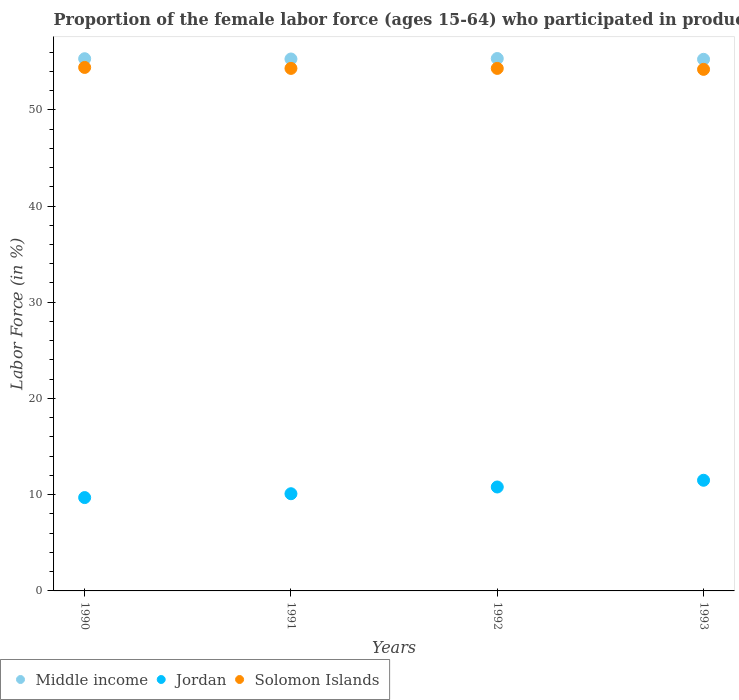What is the proportion of the female labor force who participated in production in Middle income in 1991?
Make the answer very short. 55.28. Across all years, what is the maximum proportion of the female labor force who participated in production in Jordan?
Provide a succinct answer. 11.5. Across all years, what is the minimum proportion of the female labor force who participated in production in Jordan?
Your answer should be compact. 9.7. In which year was the proportion of the female labor force who participated in production in Solomon Islands maximum?
Provide a succinct answer. 1990. What is the total proportion of the female labor force who participated in production in Solomon Islands in the graph?
Your response must be concise. 217.2. What is the difference between the proportion of the female labor force who participated in production in Middle income in 1990 and that in 1991?
Give a very brief answer. 0.03. What is the difference between the proportion of the female labor force who participated in production in Middle income in 1991 and the proportion of the female labor force who participated in production in Jordan in 1992?
Offer a very short reply. 44.48. What is the average proportion of the female labor force who participated in production in Middle income per year?
Your answer should be compact. 55.29. In the year 1993, what is the difference between the proportion of the female labor force who participated in production in Solomon Islands and proportion of the female labor force who participated in production in Jordan?
Your answer should be very brief. 42.7. What is the ratio of the proportion of the female labor force who participated in production in Solomon Islands in 1991 to that in 1993?
Your response must be concise. 1. Is the difference between the proportion of the female labor force who participated in production in Solomon Islands in 1991 and 1992 greater than the difference between the proportion of the female labor force who participated in production in Jordan in 1991 and 1992?
Ensure brevity in your answer.  Yes. What is the difference between the highest and the second highest proportion of the female labor force who participated in production in Solomon Islands?
Keep it short and to the point. 0.1. What is the difference between the highest and the lowest proportion of the female labor force who participated in production in Middle income?
Give a very brief answer. 0.08. In how many years, is the proportion of the female labor force who participated in production in Middle income greater than the average proportion of the female labor force who participated in production in Middle income taken over all years?
Ensure brevity in your answer.  2. Is the sum of the proportion of the female labor force who participated in production in Middle income in 1990 and 1991 greater than the maximum proportion of the female labor force who participated in production in Jordan across all years?
Provide a succinct answer. Yes. Is it the case that in every year, the sum of the proportion of the female labor force who participated in production in Solomon Islands and proportion of the female labor force who participated in production in Middle income  is greater than the proportion of the female labor force who participated in production in Jordan?
Ensure brevity in your answer.  Yes. Is the proportion of the female labor force who participated in production in Jordan strictly greater than the proportion of the female labor force who participated in production in Middle income over the years?
Offer a very short reply. No. Is the proportion of the female labor force who participated in production in Middle income strictly less than the proportion of the female labor force who participated in production in Solomon Islands over the years?
Your answer should be compact. No. How many dotlines are there?
Keep it short and to the point. 3. How many years are there in the graph?
Offer a very short reply. 4. What is the difference between two consecutive major ticks on the Y-axis?
Offer a terse response. 10. Are the values on the major ticks of Y-axis written in scientific E-notation?
Offer a very short reply. No. Does the graph contain grids?
Provide a succinct answer. No. Where does the legend appear in the graph?
Ensure brevity in your answer.  Bottom left. How many legend labels are there?
Your answer should be compact. 3. How are the legend labels stacked?
Keep it short and to the point. Horizontal. What is the title of the graph?
Provide a succinct answer. Proportion of the female labor force (ages 15-64) who participated in production. Does "Barbados" appear as one of the legend labels in the graph?
Offer a very short reply. No. What is the label or title of the X-axis?
Your response must be concise. Years. What is the Labor Force (in %) of Middle income in 1990?
Your answer should be compact. 55.31. What is the Labor Force (in %) in Jordan in 1990?
Your answer should be compact. 9.7. What is the Labor Force (in %) in Solomon Islands in 1990?
Ensure brevity in your answer.  54.4. What is the Labor Force (in %) in Middle income in 1991?
Give a very brief answer. 55.28. What is the Labor Force (in %) in Jordan in 1991?
Give a very brief answer. 10.1. What is the Labor Force (in %) of Solomon Islands in 1991?
Provide a succinct answer. 54.3. What is the Labor Force (in %) of Middle income in 1992?
Your answer should be very brief. 55.33. What is the Labor Force (in %) of Jordan in 1992?
Offer a very short reply. 10.8. What is the Labor Force (in %) of Solomon Islands in 1992?
Your response must be concise. 54.3. What is the Labor Force (in %) of Middle income in 1993?
Offer a very short reply. 55.24. What is the Labor Force (in %) in Jordan in 1993?
Offer a terse response. 11.5. What is the Labor Force (in %) of Solomon Islands in 1993?
Offer a very short reply. 54.2. Across all years, what is the maximum Labor Force (in %) of Middle income?
Offer a very short reply. 55.33. Across all years, what is the maximum Labor Force (in %) in Solomon Islands?
Make the answer very short. 54.4. Across all years, what is the minimum Labor Force (in %) in Middle income?
Keep it short and to the point. 55.24. Across all years, what is the minimum Labor Force (in %) of Jordan?
Give a very brief answer. 9.7. Across all years, what is the minimum Labor Force (in %) in Solomon Islands?
Make the answer very short. 54.2. What is the total Labor Force (in %) of Middle income in the graph?
Your answer should be compact. 221.15. What is the total Labor Force (in %) of Jordan in the graph?
Provide a short and direct response. 42.1. What is the total Labor Force (in %) in Solomon Islands in the graph?
Provide a succinct answer. 217.2. What is the difference between the Labor Force (in %) of Middle income in 1990 and that in 1991?
Your answer should be compact. 0.03. What is the difference between the Labor Force (in %) of Jordan in 1990 and that in 1991?
Keep it short and to the point. -0.4. What is the difference between the Labor Force (in %) in Solomon Islands in 1990 and that in 1991?
Provide a short and direct response. 0.1. What is the difference between the Labor Force (in %) in Middle income in 1990 and that in 1992?
Your answer should be very brief. -0.02. What is the difference between the Labor Force (in %) in Jordan in 1990 and that in 1992?
Your response must be concise. -1.1. What is the difference between the Labor Force (in %) of Solomon Islands in 1990 and that in 1992?
Offer a terse response. 0.1. What is the difference between the Labor Force (in %) of Middle income in 1990 and that in 1993?
Make the answer very short. 0.06. What is the difference between the Labor Force (in %) of Jordan in 1990 and that in 1993?
Offer a very short reply. -1.8. What is the difference between the Labor Force (in %) in Middle income in 1991 and that in 1992?
Give a very brief answer. -0.05. What is the difference between the Labor Force (in %) in Jordan in 1991 and that in 1992?
Provide a succinct answer. -0.7. What is the difference between the Labor Force (in %) in Solomon Islands in 1991 and that in 1992?
Provide a short and direct response. 0. What is the difference between the Labor Force (in %) of Middle income in 1991 and that in 1993?
Offer a terse response. 0.03. What is the difference between the Labor Force (in %) of Jordan in 1991 and that in 1993?
Offer a terse response. -1.4. What is the difference between the Labor Force (in %) of Middle income in 1992 and that in 1993?
Provide a succinct answer. 0.08. What is the difference between the Labor Force (in %) of Solomon Islands in 1992 and that in 1993?
Provide a short and direct response. 0.1. What is the difference between the Labor Force (in %) of Middle income in 1990 and the Labor Force (in %) of Jordan in 1991?
Your response must be concise. 45.21. What is the difference between the Labor Force (in %) in Middle income in 1990 and the Labor Force (in %) in Solomon Islands in 1991?
Give a very brief answer. 1.01. What is the difference between the Labor Force (in %) in Jordan in 1990 and the Labor Force (in %) in Solomon Islands in 1991?
Provide a short and direct response. -44.6. What is the difference between the Labor Force (in %) of Middle income in 1990 and the Labor Force (in %) of Jordan in 1992?
Your response must be concise. 44.51. What is the difference between the Labor Force (in %) in Middle income in 1990 and the Labor Force (in %) in Solomon Islands in 1992?
Provide a succinct answer. 1.01. What is the difference between the Labor Force (in %) in Jordan in 1990 and the Labor Force (in %) in Solomon Islands in 1992?
Give a very brief answer. -44.6. What is the difference between the Labor Force (in %) in Middle income in 1990 and the Labor Force (in %) in Jordan in 1993?
Your answer should be very brief. 43.81. What is the difference between the Labor Force (in %) in Middle income in 1990 and the Labor Force (in %) in Solomon Islands in 1993?
Make the answer very short. 1.11. What is the difference between the Labor Force (in %) of Jordan in 1990 and the Labor Force (in %) of Solomon Islands in 1993?
Your response must be concise. -44.5. What is the difference between the Labor Force (in %) of Middle income in 1991 and the Labor Force (in %) of Jordan in 1992?
Offer a terse response. 44.48. What is the difference between the Labor Force (in %) in Middle income in 1991 and the Labor Force (in %) in Solomon Islands in 1992?
Offer a terse response. 0.98. What is the difference between the Labor Force (in %) of Jordan in 1991 and the Labor Force (in %) of Solomon Islands in 1992?
Your answer should be compact. -44.2. What is the difference between the Labor Force (in %) of Middle income in 1991 and the Labor Force (in %) of Jordan in 1993?
Ensure brevity in your answer.  43.78. What is the difference between the Labor Force (in %) of Middle income in 1991 and the Labor Force (in %) of Solomon Islands in 1993?
Your answer should be very brief. 1.08. What is the difference between the Labor Force (in %) in Jordan in 1991 and the Labor Force (in %) in Solomon Islands in 1993?
Your answer should be compact. -44.1. What is the difference between the Labor Force (in %) of Middle income in 1992 and the Labor Force (in %) of Jordan in 1993?
Make the answer very short. 43.83. What is the difference between the Labor Force (in %) in Middle income in 1992 and the Labor Force (in %) in Solomon Islands in 1993?
Your answer should be compact. 1.13. What is the difference between the Labor Force (in %) of Jordan in 1992 and the Labor Force (in %) of Solomon Islands in 1993?
Offer a terse response. -43.4. What is the average Labor Force (in %) of Middle income per year?
Provide a succinct answer. 55.29. What is the average Labor Force (in %) in Jordan per year?
Offer a terse response. 10.53. What is the average Labor Force (in %) of Solomon Islands per year?
Provide a short and direct response. 54.3. In the year 1990, what is the difference between the Labor Force (in %) in Middle income and Labor Force (in %) in Jordan?
Offer a terse response. 45.61. In the year 1990, what is the difference between the Labor Force (in %) in Middle income and Labor Force (in %) in Solomon Islands?
Your answer should be very brief. 0.91. In the year 1990, what is the difference between the Labor Force (in %) in Jordan and Labor Force (in %) in Solomon Islands?
Ensure brevity in your answer.  -44.7. In the year 1991, what is the difference between the Labor Force (in %) of Middle income and Labor Force (in %) of Jordan?
Keep it short and to the point. 45.18. In the year 1991, what is the difference between the Labor Force (in %) in Middle income and Labor Force (in %) in Solomon Islands?
Provide a short and direct response. 0.98. In the year 1991, what is the difference between the Labor Force (in %) of Jordan and Labor Force (in %) of Solomon Islands?
Provide a short and direct response. -44.2. In the year 1992, what is the difference between the Labor Force (in %) of Middle income and Labor Force (in %) of Jordan?
Your answer should be very brief. 44.53. In the year 1992, what is the difference between the Labor Force (in %) of Middle income and Labor Force (in %) of Solomon Islands?
Provide a short and direct response. 1.03. In the year 1992, what is the difference between the Labor Force (in %) of Jordan and Labor Force (in %) of Solomon Islands?
Offer a very short reply. -43.5. In the year 1993, what is the difference between the Labor Force (in %) of Middle income and Labor Force (in %) of Jordan?
Your answer should be compact. 43.74. In the year 1993, what is the difference between the Labor Force (in %) in Middle income and Labor Force (in %) in Solomon Islands?
Provide a succinct answer. 1.04. In the year 1993, what is the difference between the Labor Force (in %) in Jordan and Labor Force (in %) in Solomon Islands?
Ensure brevity in your answer.  -42.7. What is the ratio of the Labor Force (in %) of Jordan in 1990 to that in 1991?
Give a very brief answer. 0.96. What is the ratio of the Labor Force (in %) in Middle income in 1990 to that in 1992?
Provide a succinct answer. 1. What is the ratio of the Labor Force (in %) in Jordan in 1990 to that in 1992?
Ensure brevity in your answer.  0.9. What is the ratio of the Labor Force (in %) of Solomon Islands in 1990 to that in 1992?
Keep it short and to the point. 1. What is the ratio of the Labor Force (in %) in Middle income in 1990 to that in 1993?
Keep it short and to the point. 1. What is the ratio of the Labor Force (in %) in Jordan in 1990 to that in 1993?
Offer a terse response. 0.84. What is the ratio of the Labor Force (in %) of Middle income in 1991 to that in 1992?
Give a very brief answer. 1. What is the ratio of the Labor Force (in %) of Jordan in 1991 to that in 1992?
Provide a short and direct response. 0.94. What is the ratio of the Labor Force (in %) of Solomon Islands in 1991 to that in 1992?
Keep it short and to the point. 1. What is the ratio of the Labor Force (in %) of Jordan in 1991 to that in 1993?
Provide a succinct answer. 0.88. What is the ratio of the Labor Force (in %) in Solomon Islands in 1991 to that in 1993?
Your answer should be very brief. 1. What is the ratio of the Labor Force (in %) in Middle income in 1992 to that in 1993?
Your answer should be very brief. 1. What is the ratio of the Labor Force (in %) of Jordan in 1992 to that in 1993?
Offer a terse response. 0.94. What is the difference between the highest and the second highest Labor Force (in %) of Middle income?
Ensure brevity in your answer.  0.02. What is the difference between the highest and the second highest Labor Force (in %) of Solomon Islands?
Ensure brevity in your answer.  0.1. What is the difference between the highest and the lowest Labor Force (in %) of Middle income?
Make the answer very short. 0.08. What is the difference between the highest and the lowest Labor Force (in %) in Jordan?
Offer a terse response. 1.8. 